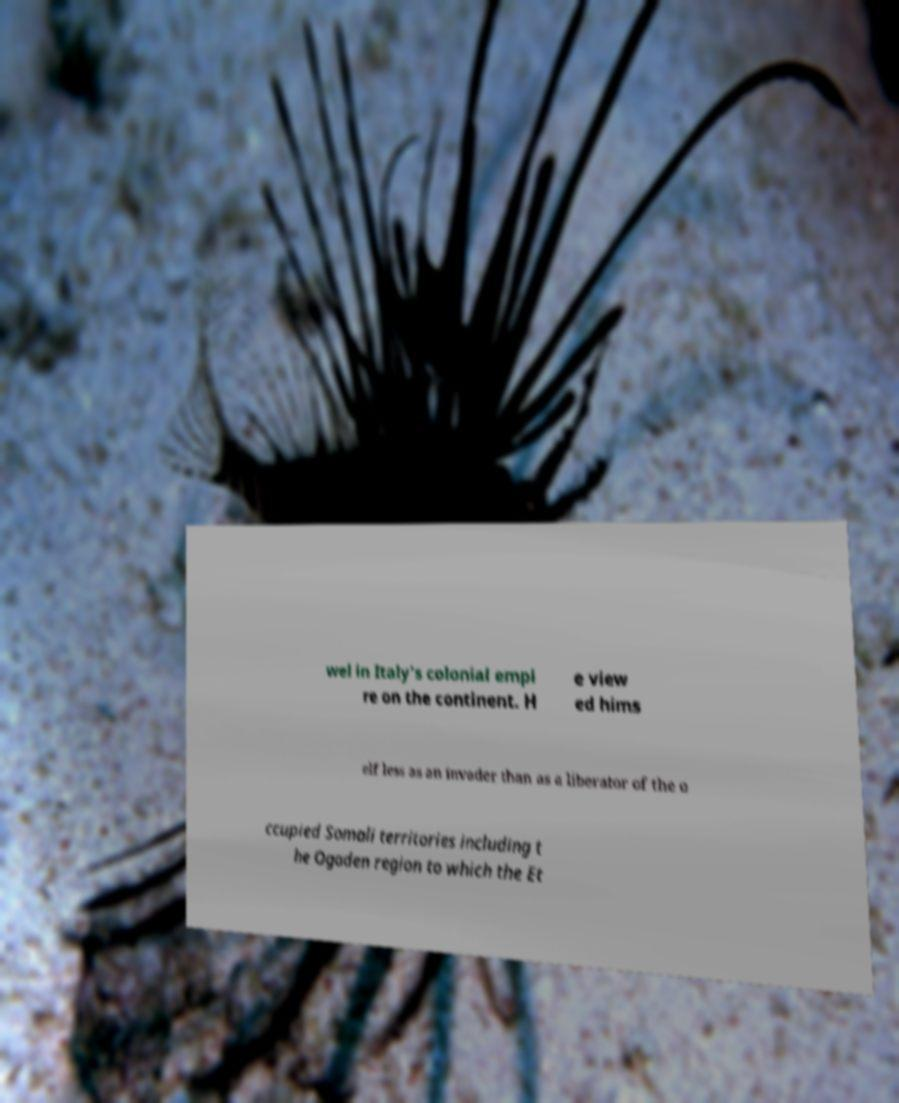There's text embedded in this image that I need extracted. Can you transcribe it verbatim? wel in Italy's colonial empi re on the continent. H e view ed hims elf less as an invader than as a liberator of the o ccupied Somali territories including t he Ogaden region to which the Et 